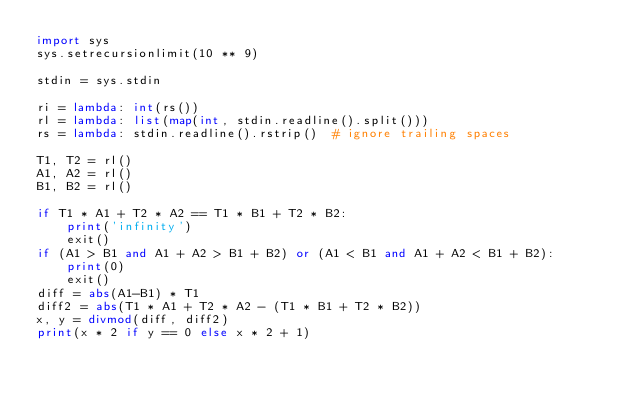<code> <loc_0><loc_0><loc_500><loc_500><_Python_>import sys
sys.setrecursionlimit(10 ** 9)

stdin = sys.stdin
 
ri = lambda: int(rs())
rl = lambda: list(map(int, stdin.readline().split()))
rs = lambda: stdin.readline().rstrip()  # ignore trailing spaces

T1, T2 = rl()
A1, A2 = rl()
B1, B2 = rl()

if T1 * A1 + T2 * A2 == T1 * B1 + T2 * B2:
    print('infinity')
    exit()
if (A1 > B1 and A1 + A2 > B1 + B2) or (A1 < B1 and A1 + A2 < B1 + B2):
    print(0)
    exit()
diff = abs(A1-B1) * T1
diff2 = abs(T1 * A1 + T2 * A2 - (T1 * B1 + T2 * B2))
x, y = divmod(diff, diff2)
print(x * 2 if y == 0 else x * 2 + 1)
</code> 